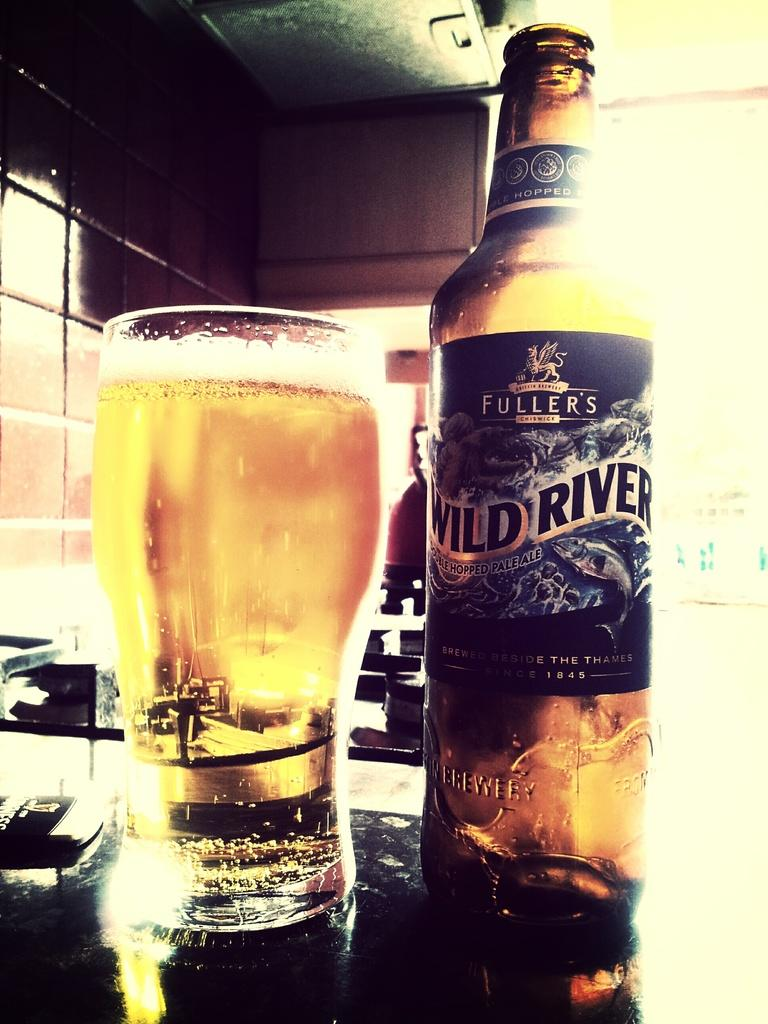<image>
Summarize the visual content of the image. An open bottle of Fullers Wild River next to a full glass of beer, 